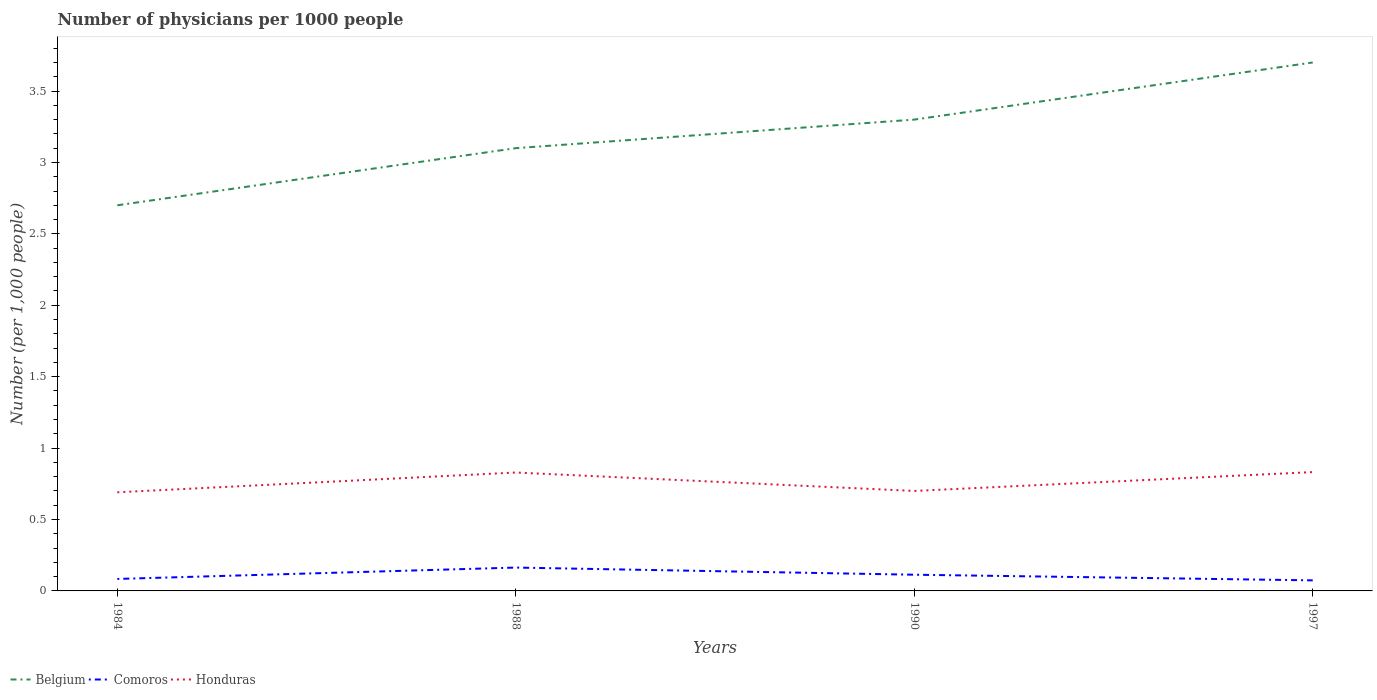How many different coloured lines are there?
Provide a short and direct response. 3. Does the line corresponding to Honduras intersect with the line corresponding to Belgium?
Ensure brevity in your answer.  No. Across all years, what is the maximum number of physicians in Comoros?
Make the answer very short. 0.07. What is the total number of physicians in Honduras in the graph?
Your answer should be very brief. -0.14. What is the difference between the highest and the second highest number of physicians in Comoros?
Offer a terse response. 0.09. How many lines are there?
Make the answer very short. 3. How many years are there in the graph?
Your answer should be very brief. 4. Does the graph contain any zero values?
Provide a succinct answer. No. Does the graph contain grids?
Your response must be concise. No. What is the title of the graph?
Your answer should be very brief. Number of physicians per 1000 people. Does "Korea (Democratic)" appear as one of the legend labels in the graph?
Offer a very short reply. No. What is the label or title of the Y-axis?
Your response must be concise. Number (per 1,0 people). What is the Number (per 1,000 people) in Comoros in 1984?
Offer a terse response. 0.08. What is the Number (per 1,000 people) in Honduras in 1984?
Your answer should be very brief. 0.69. What is the Number (per 1,000 people) of Belgium in 1988?
Keep it short and to the point. 3.1. What is the Number (per 1,000 people) of Comoros in 1988?
Provide a short and direct response. 0.16. What is the Number (per 1,000 people) in Honduras in 1988?
Give a very brief answer. 0.83. What is the Number (per 1,000 people) in Comoros in 1990?
Give a very brief answer. 0.11. What is the Number (per 1,000 people) of Honduras in 1990?
Your answer should be compact. 0.7. What is the Number (per 1,000 people) in Comoros in 1997?
Provide a short and direct response. 0.07. What is the Number (per 1,000 people) in Honduras in 1997?
Offer a terse response. 0.83. Across all years, what is the maximum Number (per 1,000 people) in Belgium?
Give a very brief answer. 3.7. Across all years, what is the maximum Number (per 1,000 people) in Comoros?
Make the answer very short. 0.16. Across all years, what is the maximum Number (per 1,000 people) in Honduras?
Your answer should be compact. 0.83. Across all years, what is the minimum Number (per 1,000 people) in Belgium?
Give a very brief answer. 2.7. Across all years, what is the minimum Number (per 1,000 people) of Comoros?
Provide a short and direct response. 0.07. Across all years, what is the minimum Number (per 1,000 people) of Honduras?
Your response must be concise. 0.69. What is the total Number (per 1,000 people) in Comoros in the graph?
Offer a terse response. 0.43. What is the total Number (per 1,000 people) in Honduras in the graph?
Your response must be concise. 3.05. What is the difference between the Number (per 1,000 people) of Belgium in 1984 and that in 1988?
Your answer should be very brief. -0.4. What is the difference between the Number (per 1,000 people) in Comoros in 1984 and that in 1988?
Offer a very short reply. -0.08. What is the difference between the Number (per 1,000 people) of Honduras in 1984 and that in 1988?
Ensure brevity in your answer.  -0.14. What is the difference between the Number (per 1,000 people) of Belgium in 1984 and that in 1990?
Keep it short and to the point. -0.6. What is the difference between the Number (per 1,000 people) in Comoros in 1984 and that in 1990?
Keep it short and to the point. -0.03. What is the difference between the Number (per 1,000 people) of Honduras in 1984 and that in 1990?
Your response must be concise. -0.01. What is the difference between the Number (per 1,000 people) in Comoros in 1984 and that in 1997?
Your answer should be compact. 0.01. What is the difference between the Number (per 1,000 people) of Honduras in 1984 and that in 1997?
Your answer should be compact. -0.14. What is the difference between the Number (per 1,000 people) of Belgium in 1988 and that in 1990?
Your answer should be compact. -0.2. What is the difference between the Number (per 1,000 people) in Comoros in 1988 and that in 1990?
Give a very brief answer. 0.05. What is the difference between the Number (per 1,000 people) of Honduras in 1988 and that in 1990?
Ensure brevity in your answer.  0.13. What is the difference between the Number (per 1,000 people) of Belgium in 1988 and that in 1997?
Offer a terse response. -0.6. What is the difference between the Number (per 1,000 people) of Comoros in 1988 and that in 1997?
Your answer should be very brief. 0.09. What is the difference between the Number (per 1,000 people) of Honduras in 1988 and that in 1997?
Provide a succinct answer. -0. What is the difference between the Number (per 1,000 people) of Comoros in 1990 and that in 1997?
Provide a succinct answer. 0.04. What is the difference between the Number (per 1,000 people) in Honduras in 1990 and that in 1997?
Offer a very short reply. -0.13. What is the difference between the Number (per 1,000 people) of Belgium in 1984 and the Number (per 1,000 people) of Comoros in 1988?
Ensure brevity in your answer.  2.54. What is the difference between the Number (per 1,000 people) of Belgium in 1984 and the Number (per 1,000 people) of Honduras in 1988?
Make the answer very short. 1.87. What is the difference between the Number (per 1,000 people) in Comoros in 1984 and the Number (per 1,000 people) in Honduras in 1988?
Your response must be concise. -0.75. What is the difference between the Number (per 1,000 people) of Belgium in 1984 and the Number (per 1,000 people) of Comoros in 1990?
Provide a succinct answer. 2.59. What is the difference between the Number (per 1,000 people) in Comoros in 1984 and the Number (per 1,000 people) in Honduras in 1990?
Offer a terse response. -0.62. What is the difference between the Number (per 1,000 people) in Belgium in 1984 and the Number (per 1,000 people) in Comoros in 1997?
Offer a terse response. 2.63. What is the difference between the Number (per 1,000 people) in Belgium in 1984 and the Number (per 1,000 people) in Honduras in 1997?
Provide a short and direct response. 1.87. What is the difference between the Number (per 1,000 people) in Comoros in 1984 and the Number (per 1,000 people) in Honduras in 1997?
Provide a short and direct response. -0.75. What is the difference between the Number (per 1,000 people) of Belgium in 1988 and the Number (per 1,000 people) of Comoros in 1990?
Your answer should be compact. 2.99. What is the difference between the Number (per 1,000 people) in Comoros in 1988 and the Number (per 1,000 people) in Honduras in 1990?
Offer a very short reply. -0.54. What is the difference between the Number (per 1,000 people) of Belgium in 1988 and the Number (per 1,000 people) of Comoros in 1997?
Ensure brevity in your answer.  3.03. What is the difference between the Number (per 1,000 people) in Belgium in 1988 and the Number (per 1,000 people) in Honduras in 1997?
Keep it short and to the point. 2.27. What is the difference between the Number (per 1,000 people) of Comoros in 1988 and the Number (per 1,000 people) of Honduras in 1997?
Your answer should be very brief. -0.67. What is the difference between the Number (per 1,000 people) of Belgium in 1990 and the Number (per 1,000 people) of Comoros in 1997?
Give a very brief answer. 3.23. What is the difference between the Number (per 1,000 people) of Belgium in 1990 and the Number (per 1,000 people) of Honduras in 1997?
Your answer should be compact. 2.47. What is the difference between the Number (per 1,000 people) of Comoros in 1990 and the Number (per 1,000 people) of Honduras in 1997?
Keep it short and to the point. -0.72. What is the average Number (per 1,000 people) of Comoros per year?
Make the answer very short. 0.11. What is the average Number (per 1,000 people) of Honduras per year?
Make the answer very short. 0.76. In the year 1984, what is the difference between the Number (per 1,000 people) of Belgium and Number (per 1,000 people) of Comoros?
Give a very brief answer. 2.62. In the year 1984, what is the difference between the Number (per 1,000 people) of Belgium and Number (per 1,000 people) of Honduras?
Give a very brief answer. 2.01. In the year 1984, what is the difference between the Number (per 1,000 people) of Comoros and Number (per 1,000 people) of Honduras?
Give a very brief answer. -0.61. In the year 1988, what is the difference between the Number (per 1,000 people) in Belgium and Number (per 1,000 people) in Comoros?
Your answer should be very brief. 2.94. In the year 1988, what is the difference between the Number (per 1,000 people) in Belgium and Number (per 1,000 people) in Honduras?
Offer a very short reply. 2.27. In the year 1988, what is the difference between the Number (per 1,000 people) of Comoros and Number (per 1,000 people) of Honduras?
Your answer should be compact. -0.67. In the year 1990, what is the difference between the Number (per 1,000 people) in Belgium and Number (per 1,000 people) in Comoros?
Provide a short and direct response. 3.19. In the year 1990, what is the difference between the Number (per 1,000 people) in Comoros and Number (per 1,000 people) in Honduras?
Keep it short and to the point. -0.59. In the year 1997, what is the difference between the Number (per 1,000 people) of Belgium and Number (per 1,000 people) of Comoros?
Give a very brief answer. 3.63. In the year 1997, what is the difference between the Number (per 1,000 people) in Belgium and Number (per 1,000 people) in Honduras?
Give a very brief answer. 2.87. In the year 1997, what is the difference between the Number (per 1,000 people) in Comoros and Number (per 1,000 people) in Honduras?
Your answer should be very brief. -0.76. What is the ratio of the Number (per 1,000 people) in Belgium in 1984 to that in 1988?
Your answer should be very brief. 0.87. What is the ratio of the Number (per 1,000 people) in Comoros in 1984 to that in 1988?
Provide a succinct answer. 0.51. What is the ratio of the Number (per 1,000 people) in Honduras in 1984 to that in 1988?
Give a very brief answer. 0.83. What is the ratio of the Number (per 1,000 people) of Belgium in 1984 to that in 1990?
Your response must be concise. 0.82. What is the ratio of the Number (per 1,000 people) of Comoros in 1984 to that in 1990?
Provide a succinct answer. 0.74. What is the ratio of the Number (per 1,000 people) of Honduras in 1984 to that in 1990?
Your answer should be compact. 0.99. What is the ratio of the Number (per 1,000 people) of Belgium in 1984 to that in 1997?
Make the answer very short. 0.73. What is the ratio of the Number (per 1,000 people) in Comoros in 1984 to that in 1997?
Keep it short and to the point. 1.13. What is the ratio of the Number (per 1,000 people) of Honduras in 1984 to that in 1997?
Give a very brief answer. 0.83. What is the ratio of the Number (per 1,000 people) in Belgium in 1988 to that in 1990?
Offer a very short reply. 0.94. What is the ratio of the Number (per 1,000 people) of Comoros in 1988 to that in 1990?
Make the answer very short. 1.44. What is the ratio of the Number (per 1,000 people) of Honduras in 1988 to that in 1990?
Keep it short and to the point. 1.18. What is the ratio of the Number (per 1,000 people) in Belgium in 1988 to that in 1997?
Your response must be concise. 0.84. What is the ratio of the Number (per 1,000 people) in Comoros in 1988 to that in 1997?
Offer a very short reply. 2.21. What is the ratio of the Number (per 1,000 people) in Belgium in 1990 to that in 1997?
Ensure brevity in your answer.  0.89. What is the ratio of the Number (per 1,000 people) in Comoros in 1990 to that in 1997?
Offer a terse response. 1.53. What is the ratio of the Number (per 1,000 people) of Honduras in 1990 to that in 1997?
Your response must be concise. 0.84. What is the difference between the highest and the second highest Number (per 1,000 people) in Belgium?
Ensure brevity in your answer.  0.4. What is the difference between the highest and the second highest Number (per 1,000 people) of Comoros?
Offer a terse response. 0.05. What is the difference between the highest and the second highest Number (per 1,000 people) in Honduras?
Provide a short and direct response. 0. What is the difference between the highest and the lowest Number (per 1,000 people) in Belgium?
Give a very brief answer. 1. What is the difference between the highest and the lowest Number (per 1,000 people) in Comoros?
Offer a terse response. 0.09. What is the difference between the highest and the lowest Number (per 1,000 people) of Honduras?
Offer a terse response. 0.14. 